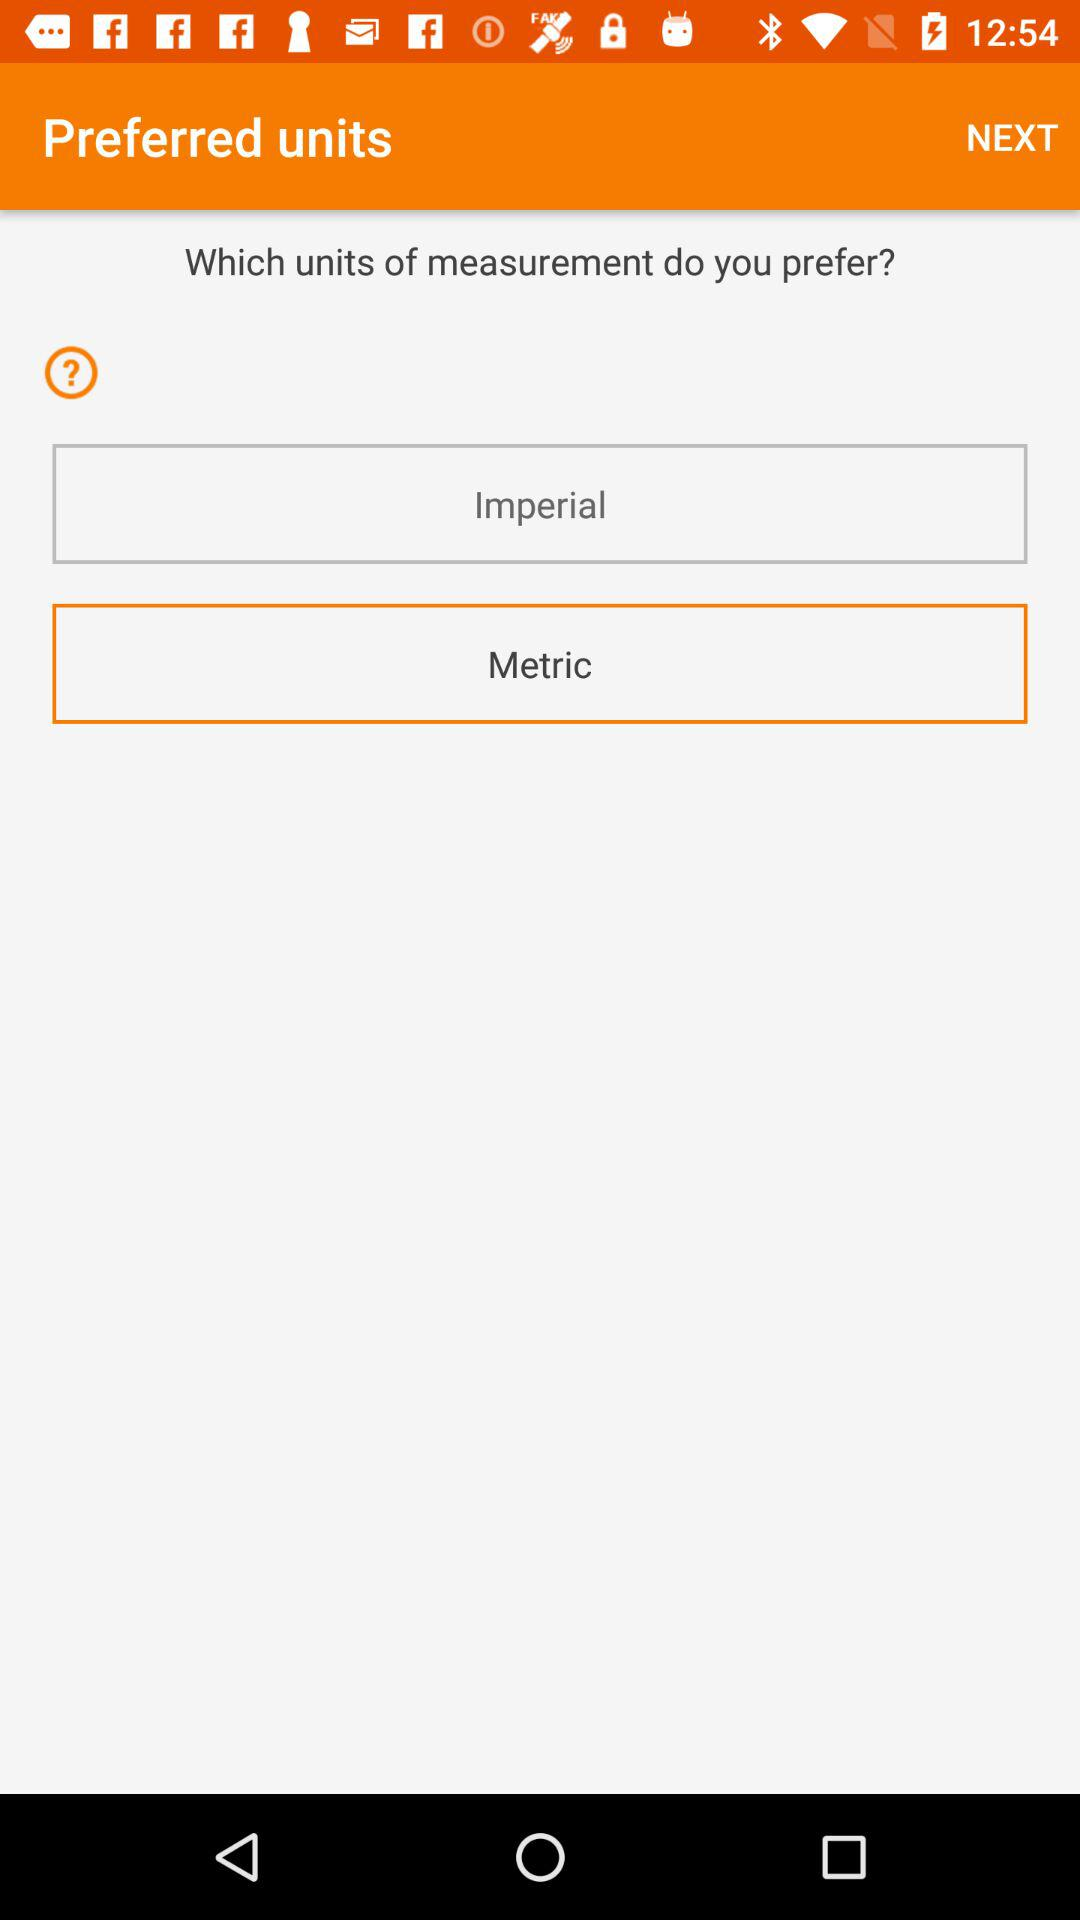How many units of measurement does the user have to choose from?
Answer the question using a single word or phrase. 2 